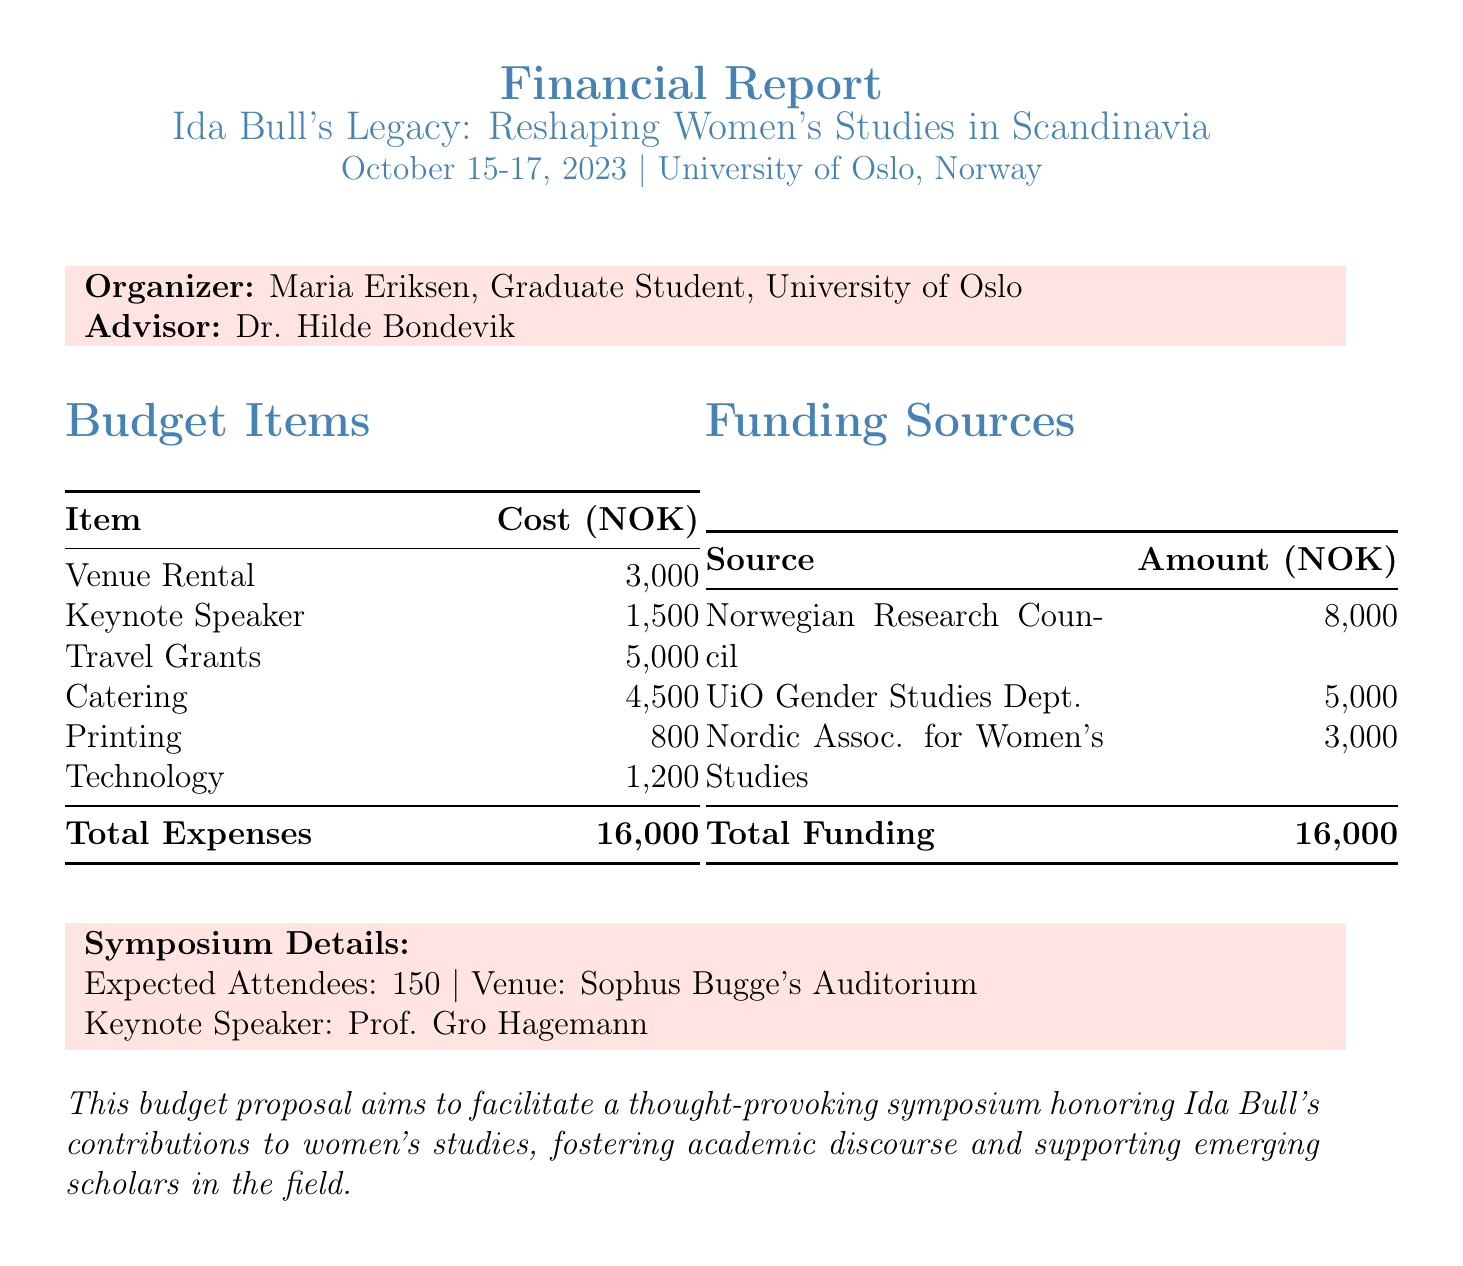What is the title of the symposium? The title of the symposium is clearly stated in the document.
Answer: Ida Bull's Legacy: Reshaping Women's Studies in Scandinavia How many attendees are expected? The expected number of attendees is mentioned in the symposium details.
Answer: 150 What is the cost for the keynote speaker? The document specifies the honorarium cost for the keynote speaker.
Answer: 1500 What is the total cost of the budget items? The total expenses are summed up in the budget section of the document.
Answer: 16000 Which venue will host the symposium? The document identifies the location where the event will take place.
Answer: University of Oslo, Norway Who is the organizer of the symposium? The name of the organizer is provided in the organizer info section of the document.
Answer: Maria Eriksen What is the funding amount from the Norwegian Research Council? The amount from this specific funding source is listed in the funding section.
Answer: 8000 How many travel grants are being offered? The number of travel grants mentioned in the budget items gives this information.
Answer: 10 What is the cost associated with catering? The document outlines the specific costs attributed to catering in the budget section.
Answer: 4500 